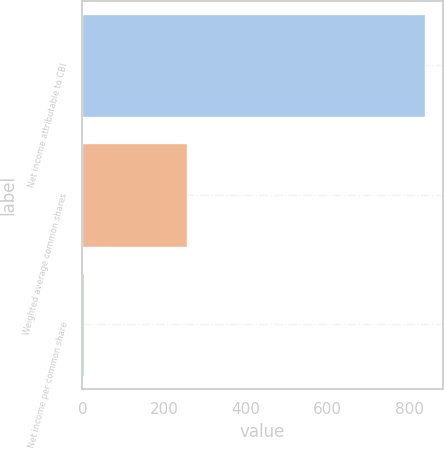Convert chart to OTSL. <chart><loc_0><loc_0><loc_500><loc_500><bar_chart><fcel>Net income attributable to CBI<fcel>Weighted average common shares<fcel>Net income per common share<nl><fcel>839.3<fcel>254.7<fcel>4.17<nl></chart> 